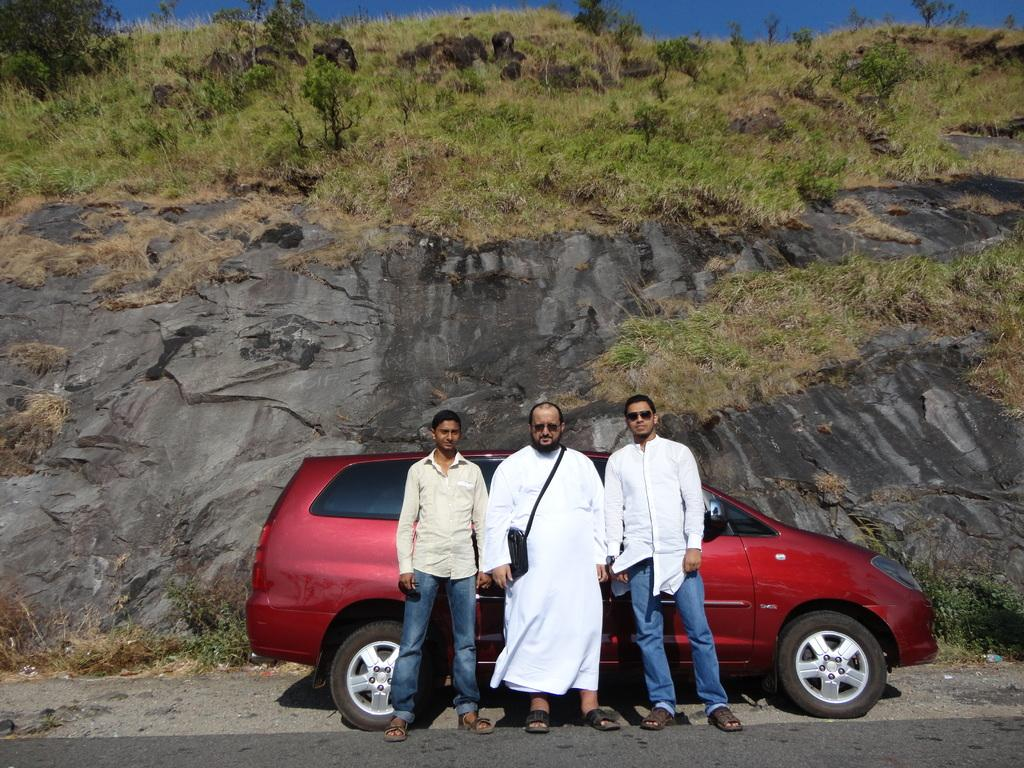How many people are in the image? There are three people in the image. What are the people doing in the image? The people are standing in front of a car. Where is the car located in the image? The car is on the road. What can be seen in the background of the image? There is a mountain in the background of the image. What type of vegetation is present on the mountain? The mountain has plants and grass on it. How many legs can be seen on the lead in the image? There is no lead present in the image, and therefore no legs can be seen on it. 